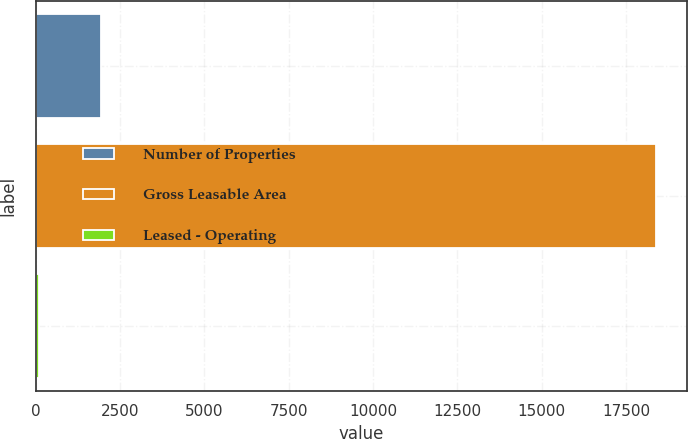Convert chart. <chart><loc_0><loc_0><loc_500><loc_500><bar_chart><fcel>Number of Properties<fcel>Gross Leasable Area<fcel>Leased - Operating<nl><fcel>1925.22<fcel>18399<fcel>94.8<nl></chart> 